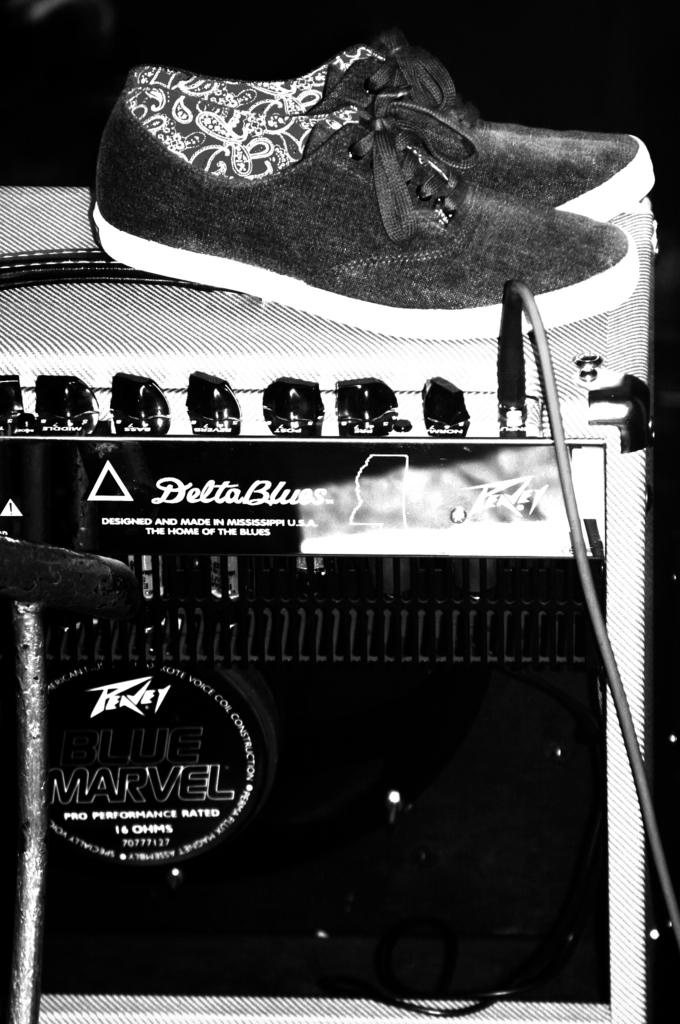What is the main object in the front of the image? There is a device in the front of the image. What is connected to the device in the image? There is a cable in the front of the image. What type of footwear is visible in the image? There is a pair of shoes in the front of the image. Can you describe the background of the image? The background of the image is dark. How many objects are in the front of the image? There are at least four objects in the front of the image: a device, a cable, a pair of shoes, and another object. Reasoning: Let' Let's think step by step in order to produce the conversation. We start by identifying the main subject in the image, which is the device. Then, we expand the conversation to include other items that are also visible, such as the cable, the pair of shoes, and the other object. Each question is designed to elicit a specific detail about the image that is known from the provided facts. Absurd Question/Answer: What type of arithmetic problem is the uncle solving in the image? There is no uncle or arithmetic problem present in the image. What type of patch is visible on the shoes in the image? There is no patch visible on the shoes in the image. What type of arithmetic problem is the uncle solving in the image? There is no uncle or arithmetic problem present in the image. 